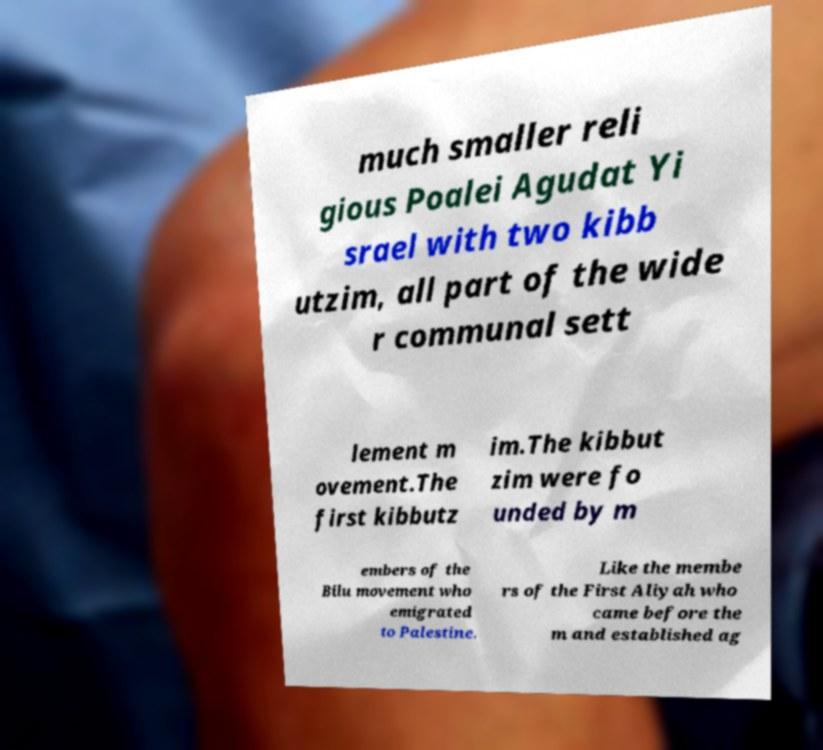What messages or text are displayed in this image? I need them in a readable, typed format. much smaller reli gious Poalei Agudat Yi srael with two kibb utzim, all part of the wide r communal sett lement m ovement.The first kibbutz im.The kibbut zim were fo unded by m embers of the Bilu movement who emigrated to Palestine. Like the membe rs of the First Aliyah who came before the m and established ag 